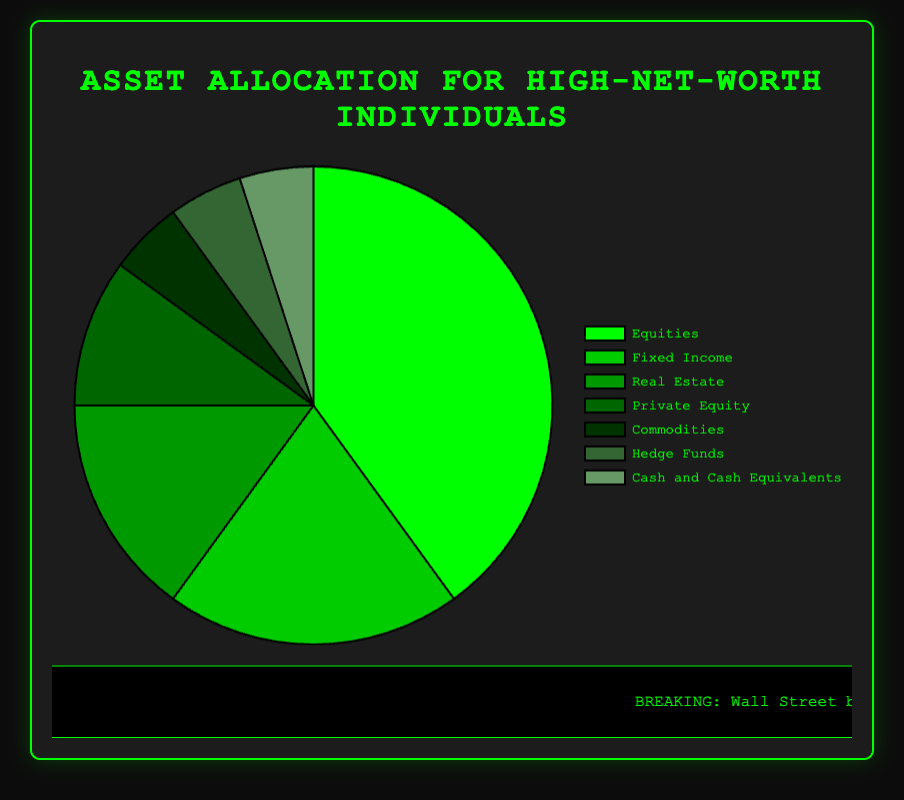Which asset class has the highest allocation in the portfolio? The pie chart shows that "Equities" has the largest slice, indicating it has the highest allocation at 40%
Answer: Equities How does the allocation to Real Estate compare to Private Equity? The pie chart shows that Real Estate is allocated 15%, while Private Equity is allocated 10%. Therefore, Real Estate has a higher allocation than Private Equity.
Answer: Real Estate What is the combined allocation of Commodities and Hedge Funds? The pie chart indicates that Commodities are allocated 5% and Hedge Funds are also allocated 5%. The combined allocation is 5% + 5% = 10%
Answer: 10% Which asset class allocations are less than 10%? By examining the pie chart, the asset classes with less than 10% allocations are Commodities, Hedge Funds, and Cash and Cash Equivalents, each with 5%
Answer: Commodities, Hedge Funds, Cash and Cash Equivalents What is the percentage difference between the allocations to Equities and Fixed Income? The pie chart shows that Equities are allocated 40% and Fixed Income is allocated 20%. The difference is 40% - 20% = 20%
Answer: 20% How does the allocation to Equities compare to the total allocation of Real Estate, Private Equity, and Cash and Cash Equivalents? The pie chart shows Equities at 40%. Real Estate is 15%, Private Equity is 10%, and Cash and Cash Equivalents are 5%, summing up to 15% + 10% + 5% = 30%. So, 40% (Equities) is greater than 30% (combined)
Answer: Equities higher Which asset class is represented by the darkest shade of green? The pie chart indicates the darkest shade of green represents "Equities"
Answer: Equities What is the sum of the allocations for Fixed Income, Real Estate, and Commodities? According to the pie chart, Fixed Income is 20%, Real Estate is 15%, and Commodities are 5%. The sum is 20% + 15% + 5% = 40%
Answer: 40% Which asset classes have exactly the same allocation? The pie chart shows that Commodities, Hedge Funds, and Cash and Cash Equivalents each have an allocation of 5%
Answer: Commodities, Hedge Funds, Cash and Cash Equivalents What proportion of the total allocation is represented by both the Real Estate and Private Equity asset classes together? The pie chart shows Real Estate has 15% and Private Equity has 10%. The combined proportion is 15% + 10% = 25%
Answer: 25% 